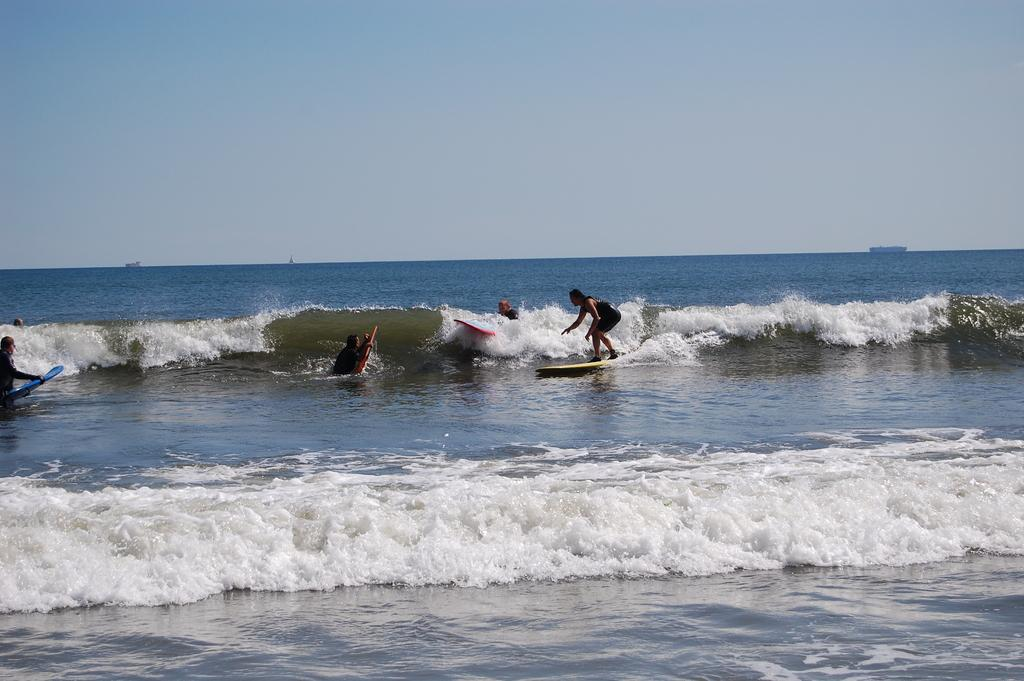What activity are the people in the image engaged in? The people in the image are surfing. What natural phenomenon is present in the image? There are tides in the ocean. What is the condition of the sky in the image? The sky is clear in the image. What type of headwear is being worn by the surfers in the image? There is no information about headwear in the image; the focus is on the people surfing and the ocean tides. 